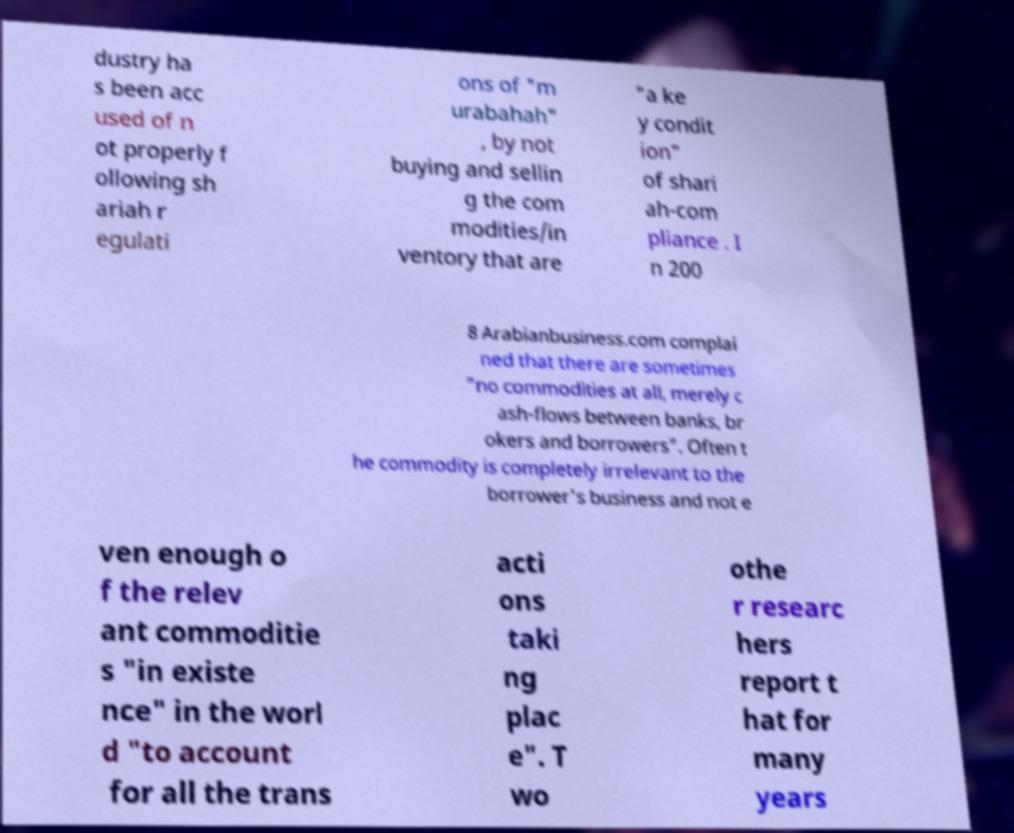Please identify and transcribe the text found in this image. dustry ha s been acc used of n ot properly f ollowing sh ariah r egulati ons of "m urabahah" , by not buying and sellin g the com modities/in ventory that are "a ke y condit ion" of shari ah-com pliance . I n 200 8 Arabianbusiness.com complai ned that there are sometimes "no commodities at all, merely c ash-flows between banks, br okers and borrowers". Often t he commodity is completely irrelevant to the borrower's business and not e ven enough o f the relev ant commoditie s "in existe nce" in the worl d "to account for all the trans acti ons taki ng plac e". T wo othe r researc hers report t hat for many years 